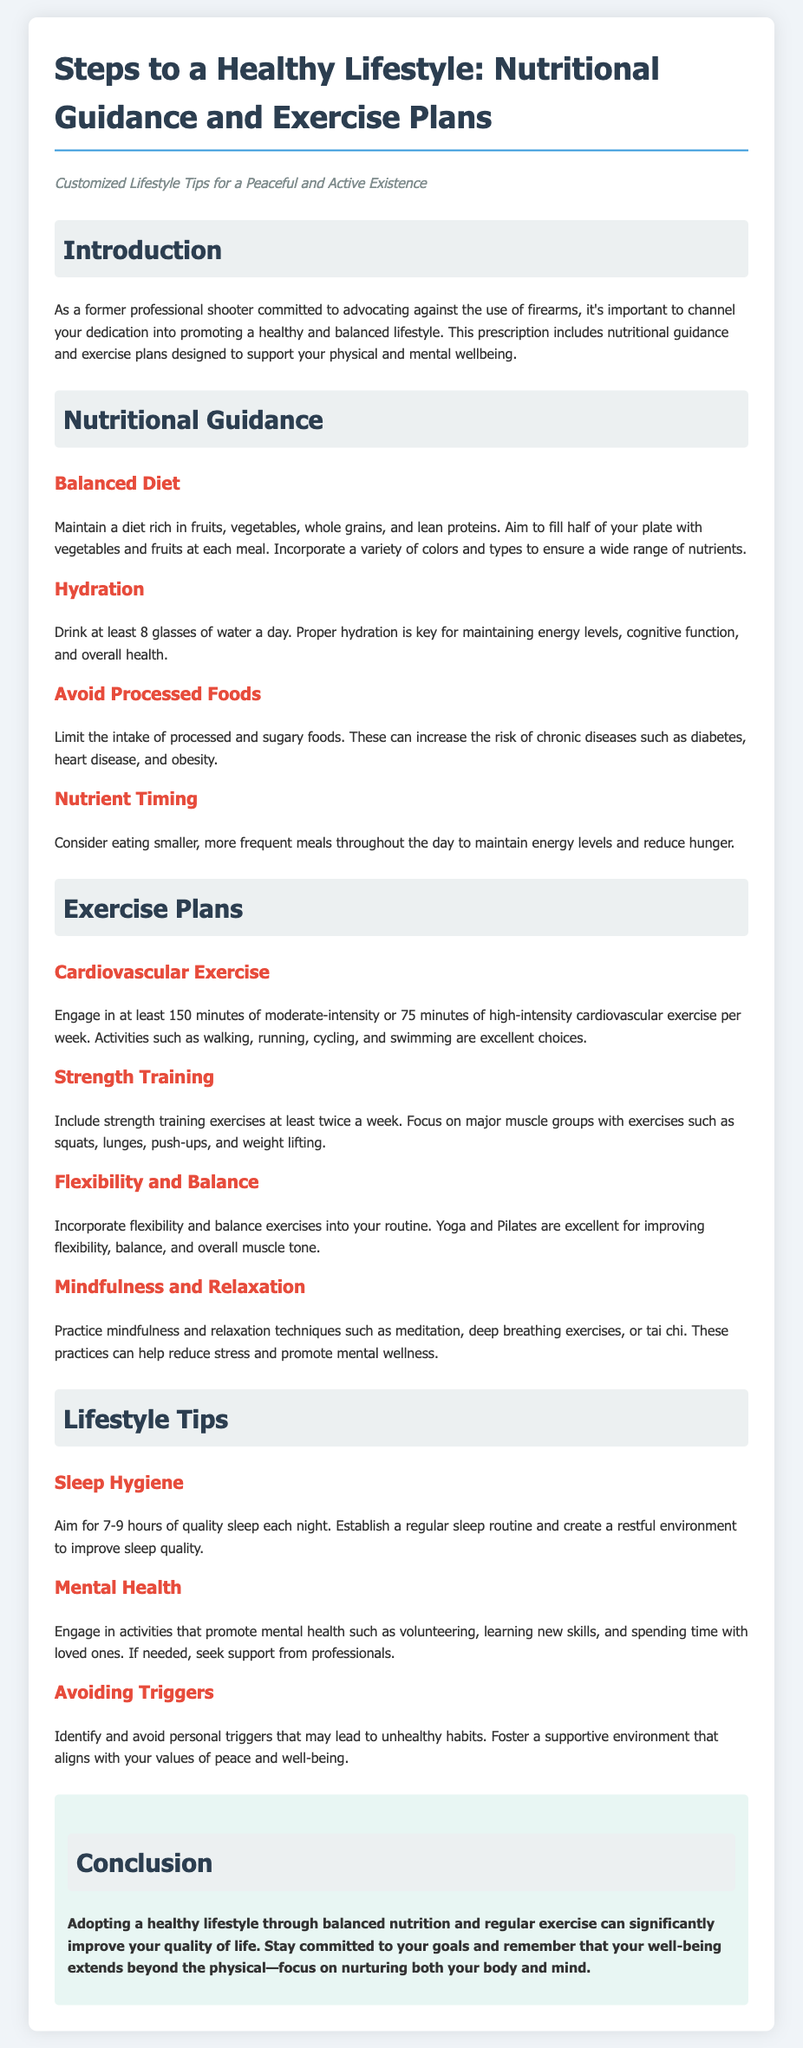What is the minimum duration of cardiovascular exercise recommended? The document states to engage in at least 150 minutes of moderate-intensity or 75 minutes of high-intensity cardiovascular exercise per week.
Answer: 150 minutes What should half of your plate consist of at each meal? According to the nutritional guidance, aim to fill half of your plate with vegetables and fruits at each meal.
Answer: Vegetables and fruits How often should strength training exercises be included in a routine? The exercise plans recommend including strength training exercises at least twice a week.
Answer: Twice a week What is the suggested amount of sleep per night? The document advises aiming for 7-9 hours of quality sleep each night.
Answer: 7-9 hours What types of exercises improve flexibility and balance? The document suggests that yoga and Pilates are excellent for improving flexibility, balance, and overall muscle tone.
Answer: Yoga and Pilates What is a key method to reduce stress mentioned in the document? It emphasizes practicing mindfulness and relaxation techniques, such as meditation, deep breathing exercises, or tai chi.
Answer: Mindfulness What should be limited to decrease the risk of chronic diseases? The nutritional guidance advises to limit the intake of processed and sugary foods.
Answer: Processed and sugary foods What should you do to create a restful environment for sleep? The document hints at establishing a regular sleep routine and creating a restful environment to improve sleep quality.
Answer: Establish a regular sleep routine What type of activities promote mental health according to the document? Engaging in activities like volunteering, learning new skills, and spending time with loved ones promotes mental health.
Answer: Volunteering 